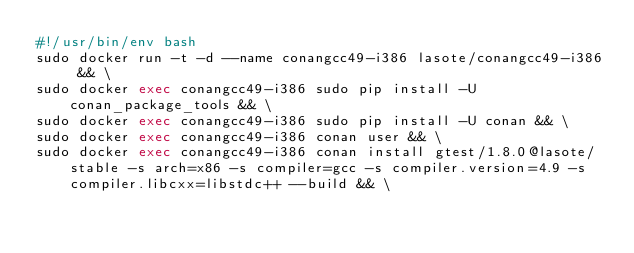Convert code to text. <code><loc_0><loc_0><loc_500><loc_500><_Bash_>#!/usr/bin/env bash
sudo docker run -t -d --name conangcc49-i386 lasote/conangcc49-i386 && \
sudo docker exec conangcc49-i386 sudo pip install -U conan_package_tools && \
sudo docker exec conangcc49-i386 sudo pip install -U conan && \
sudo docker exec conangcc49-i386 conan user && \
sudo docker exec conangcc49-i386 conan install gtest/1.8.0@lasote/stable -s arch=x86 -s compiler=gcc -s compiler.version=4.9 -s compiler.libcxx=libstdc++ --build && \</code> 